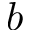Convert formula to latex. <formula><loc_0><loc_0><loc_500><loc_500>b</formula> 